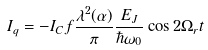Convert formula to latex. <formula><loc_0><loc_0><loc_500><loc_500>I _ { q } = - I _ { C } f \frac { \lambda ^ { 2 } ( \alpha ) } { \pi } \frac { E _ { J } } { \hbar { \omega } _ { 0 } } \cos 2 \Omega _ { r } t</formula> 